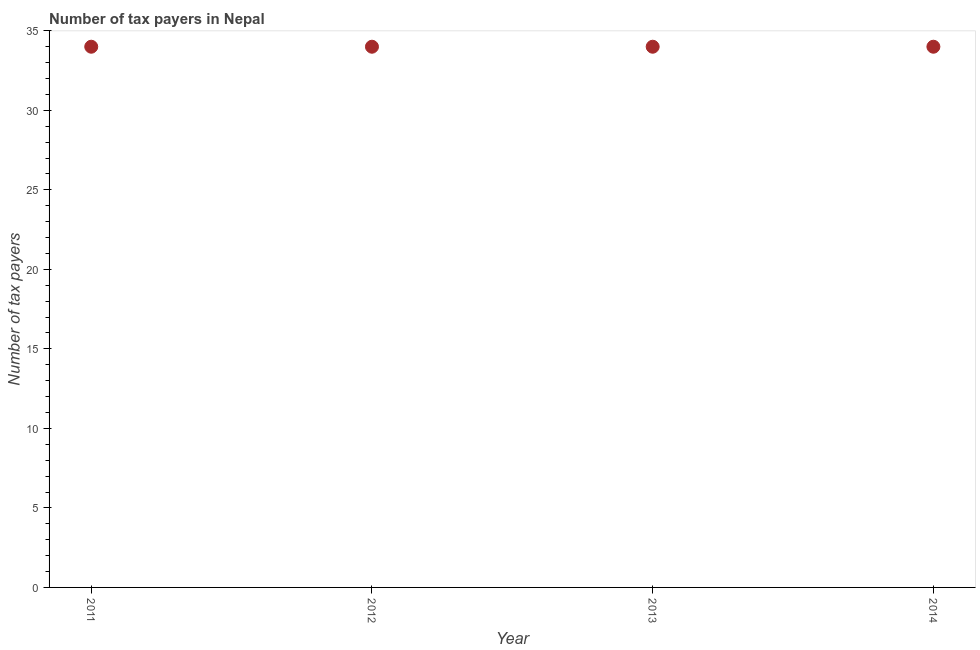What is the number of tax payers in 2014?
Make the answer very short. 34. Across all years, what is the maximum number of tax payers?
Your answer should be compact. 34. Across all years, what is the minimum number of tax payers?
Your answer should be very brief. 34. In which year was the number of tax payers maximum?
Your answer should be very brief. 2011. In which year was the number of tax payers minimum?
Offer a very short reply. 2011. What is the sum of the number of tax payers?
Provide a succinct answer. 136. What is the difference between the number of tax payers in 2011 and 2013?
Give a very brief answer. 0. What is the median number of tax payers?
Your response must be concise. 34. Do a majority of the years between 2012 and 2011 (inclusive) have number of tax payers greater than 7 ?
Your response must be concise. No. What is the difference between the highest and the lowest number of tax payers?
Your response must be concise. 0. How many years are there in the graph?
Your answer should be very brief. 4. Are the values on the major ticks of Y-axis written in scientific E-notation?
Your answer should be very brief. No. Does the graph contain any zero values?
Provide a succinct answer. No. Does the graph contain grids?
Make the answer very short. No. What is the title of the graph?
Keep it short and to the point. Number of tax payers in Nepal. What is the label or title of the X-axis?
Provide a succinct answer. Year. What is the label or title of the Y-axis?
Give a very brief answer. Number of tax payers. What is the Number of tax payers in 2011?
Offer a terse response. 34. What is the Number of tax payers in 2012?
Offer a very short reply. 34. What is the Number of tax payers in 2014?
Your response must be concise. 34. What is the difference between the Number of tax payers in 2011 and 2013?
Offer a very short reply. 0. What is the difference between the Number of tax payers in 2011 and 2014?
Keep it short and to the point. 0. What is the difference between the Number of tax payers in 2012 and 2014?
Your response must be concise. 0. What is the difference between the Number of tax payers in 2013 and 2014?
Give a very brief answer. 0. What is the ratio of the Number of tax payers in 2011 to that in 2012?
Give a very brief answer. 1. What is the ratio of the Number of tax payers in 2011 to that in 2013?
Provide a succinct answer. 1. What is the ratio of the Number of tax payers in 2011 to that in 2014?
Give a very brief answer. 1. What is the ratio of the Number of tax payers in 2013 to that in 2014?
Your answer should be very brief. 1. 